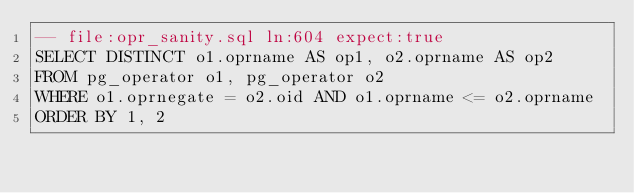Convert code to text. <code><loc_0><loc_0><loc_500><loc_500><_SQL_>-- file:opr_sanity.sql ln:604 expect:true
SELECT DISTINCT o1.oprname AS op1, o2.oprname AS op2
FROM pg_operator o1, pg_operator o2
WHERE o1.oprnegate = o2.oid AND o1.oprname <= o2.oprname
ORDER BY 1, 2
</code> 